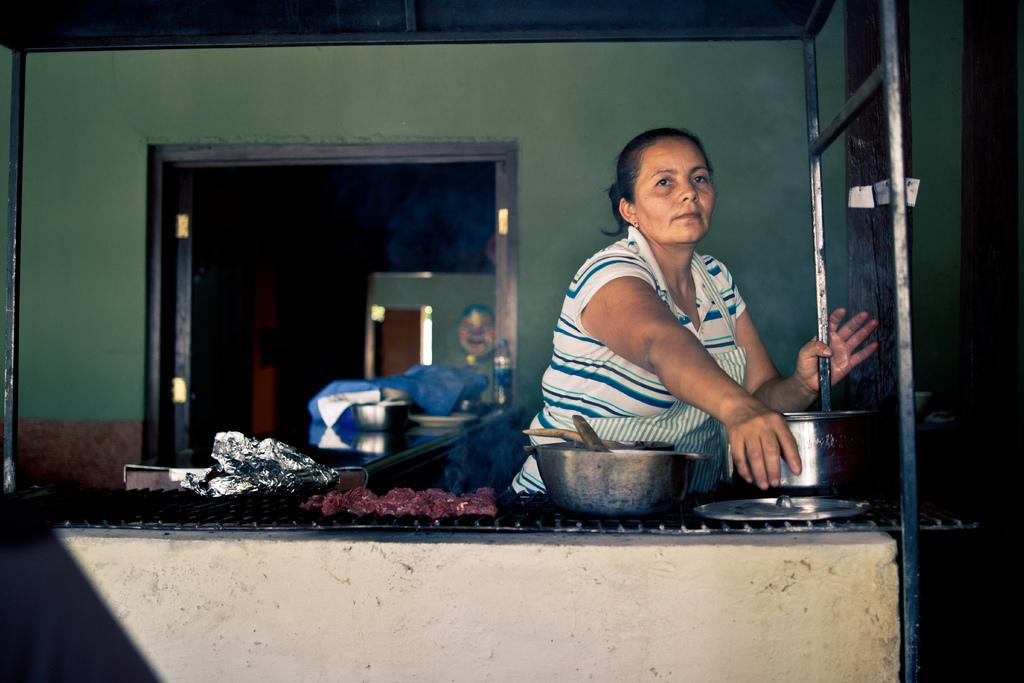What type of structure can be seen in the image? There is a wall in the image. Is there an entrance visible in the image? Yes, there is a door in the image. Can you describe the woman in the image? There is a woman wearing a white dress in the image. What type of dish is present in the image? There is a dish in the image. How many bowls are visible in the image? There are bowls in the image. How many uncles are present in the image? There is no uncle present in the image. What type of wilderness can be seen in the background of the image? There is no wilderness visible in the image; it is focused on the wall, door, woman, dish, and bowls. 